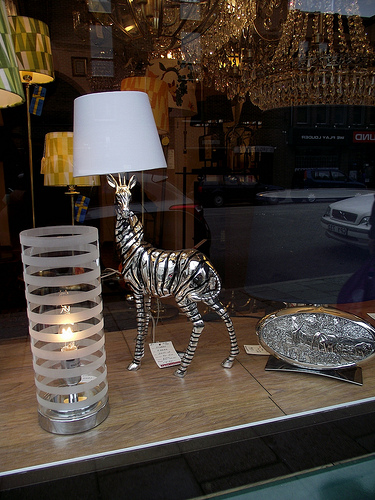<image>
Is the giraffe under the lampshade? Yes. The giraffe is positioned underneath the lampshade, with the lampshade above it in the vertical space. Is the giraffe under the lamp? Yes. The giraffe is positioned underneath the lamp, with the lamp above it in the vertical space. Is the car in the window? Yes. The car is contained within or inside the window, showing a containment relationship. Is the zebra lamp in front of the cylinder lamp? No. The zebra lamp is not in front of the cylinder lamp. The spatial positioning shows a different relationship between these objects. 